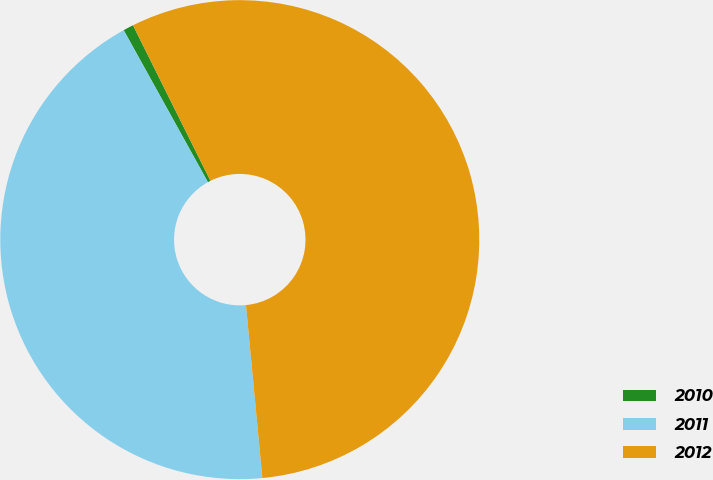Convert chart to OTSL. <chart><loc_0><loc_0><loc_500><loc_500><pie_chart><fcel>2010<fcel>2011<fcel>2012<nl><fcel>0.7%<fcel>43.45%<fcel>55.85%<nl></chart> 